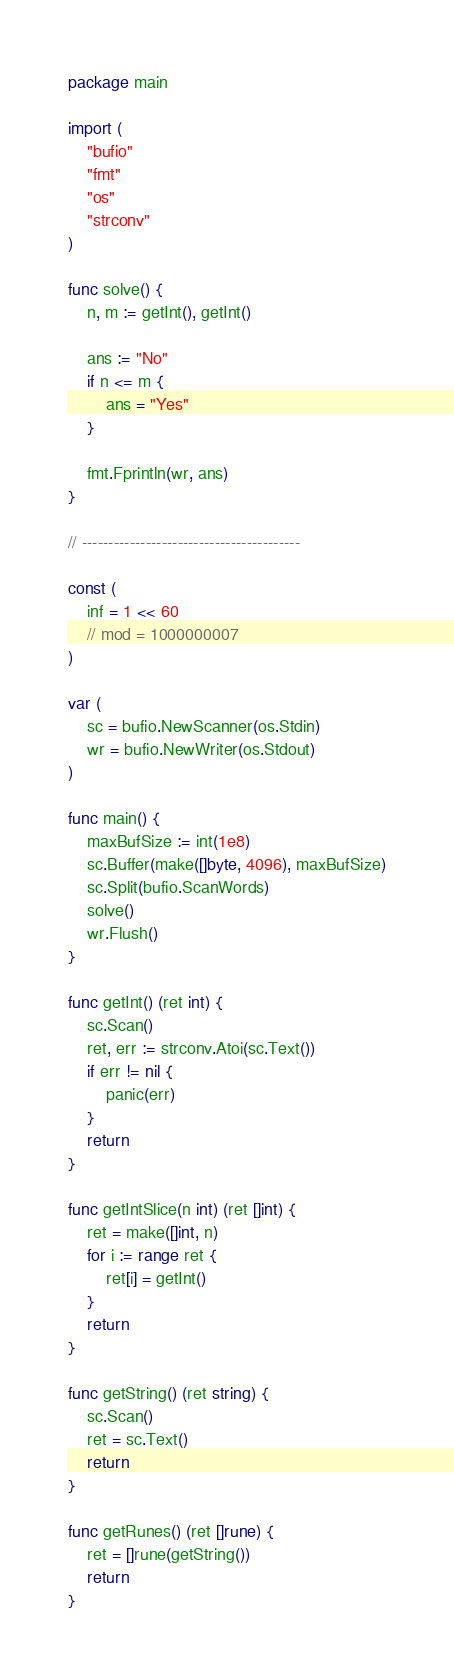<code> <loc_0><loc_0><loc_500><loc_500><_Go_>package main

import (
	"bufio"
	"fmt"
	"os"
	"strconv"
)

func solve() {
	n, m := getInt(), getInt()

	ans := "No"
	if n <= m {
		ans = "Yes"
	}

	fmt.Fprintln(wr, ans)
}

// -----------------------------------------

const (
	inf = 1 << 60
	// mod = 1000000007
)

var (
	sc = bufio.NewScanner(os.Stdin)
	wr = bufio.NewWriter(os.Stdout)
)

func main() {
	maxBufSize := int(1e8)
	sc.Buffer(make([]byte, 4096), maxBufSize)
	sc.Split(bufio.ScanWords)
	solve()
	wr.Flush()
}

func getInt() (ret int) {
	sc.Scan()
	ret, err := strconv.Atoi(sc.Text())
	if err != nil {
		panic(err)
	}
	return
}

func getIntSlice(n int) (ret []int) {
	ret = make([]int, n)
	for i := range ret {
		ret[i] = getInt()
	}
	return
}

func getString() (ret string) {
	sc.Scan()
	ret = sc.Text()
	return
}

func getRunes() (ret []rune) {
	ret = []rune(getString())
	return
}
</code> 